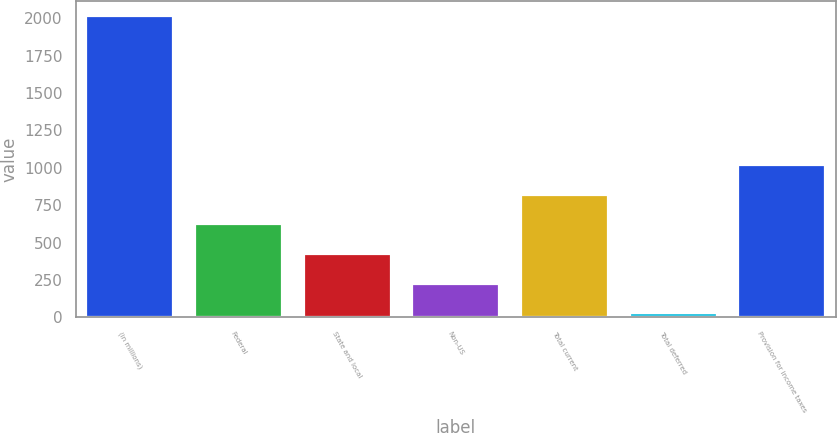Convert chart to OTSL. <chart><loc_0><loc_0><loc_500><loc_500><bar_chart><fcel>(in millions)<fcel>Federal<fcel>State and local<fcel>Non-US<fcel>Total current<fcel>Total deferred<fcel>Provision for income taxes<nl><fcel>2014<fcel>622.4<fcel>423.6<fcel>224.8<fcel>821.2<fcel>26<fcel>1020<nl></chart> 